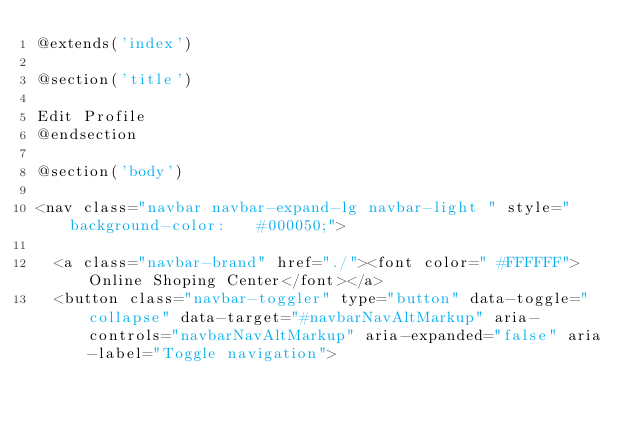Convert code to text. <code><loc_0><loc_0><loc_500><loc_500><_PHP_>@extends('index')

@section('title')

Edit Profile
@endsection

@section('body')

<nav class="navbar navbar-expand-lg navbar-light " style="background-color:   #000050;">

  <a class="navbar-brand" href="./"><font color=" #FFFFFF">Online Shoping Center</font></a>
  <button class="navbar-toggler" type="button" data-toggle="collapse" data-target="#navbarNavAltMarkup" aria-controls="navbarNavAltMarkup" aria-expanded="false" aria-label="Toggle navigation"></code> 